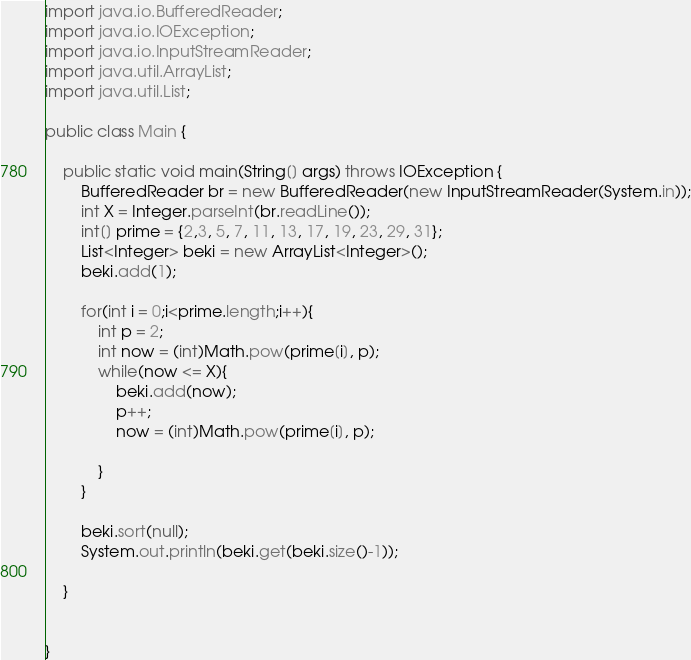<code> <loc_0><loc_0><loc_500><loc_500><_Java_>import java.io.BufferedReader;
import java.io.IOException;
import java.io.InputStreamReader;
import java.util.ArrayList;
import java.util.List;

public class Main {

	public static void main(String[] args) throws IOException {
		BufferedReader br = new BufferedReader(new InputStreamReader(System.in));
		int X = Integer.parseInt(br.readLine());
		int[] prime = {2,3, 5, 7, 11, 13, 17, 19, 23, 29, 31};
		List<Integer> beki = new ArrayList<Integer>();
		beki.add(1);

		for(int i = 0;i<prime.length;i++){
			int p = 2;
			int now = (int)Math.pow(prime[i], p);
			while(now <= X){
				beki.add(now);
				p++;
				now = (int)Math.pow(prime[i], p);

			}
		}

		beki.sort(null);
		System.out.println(beki.get(beki.size()-1));

	}


}</code> 